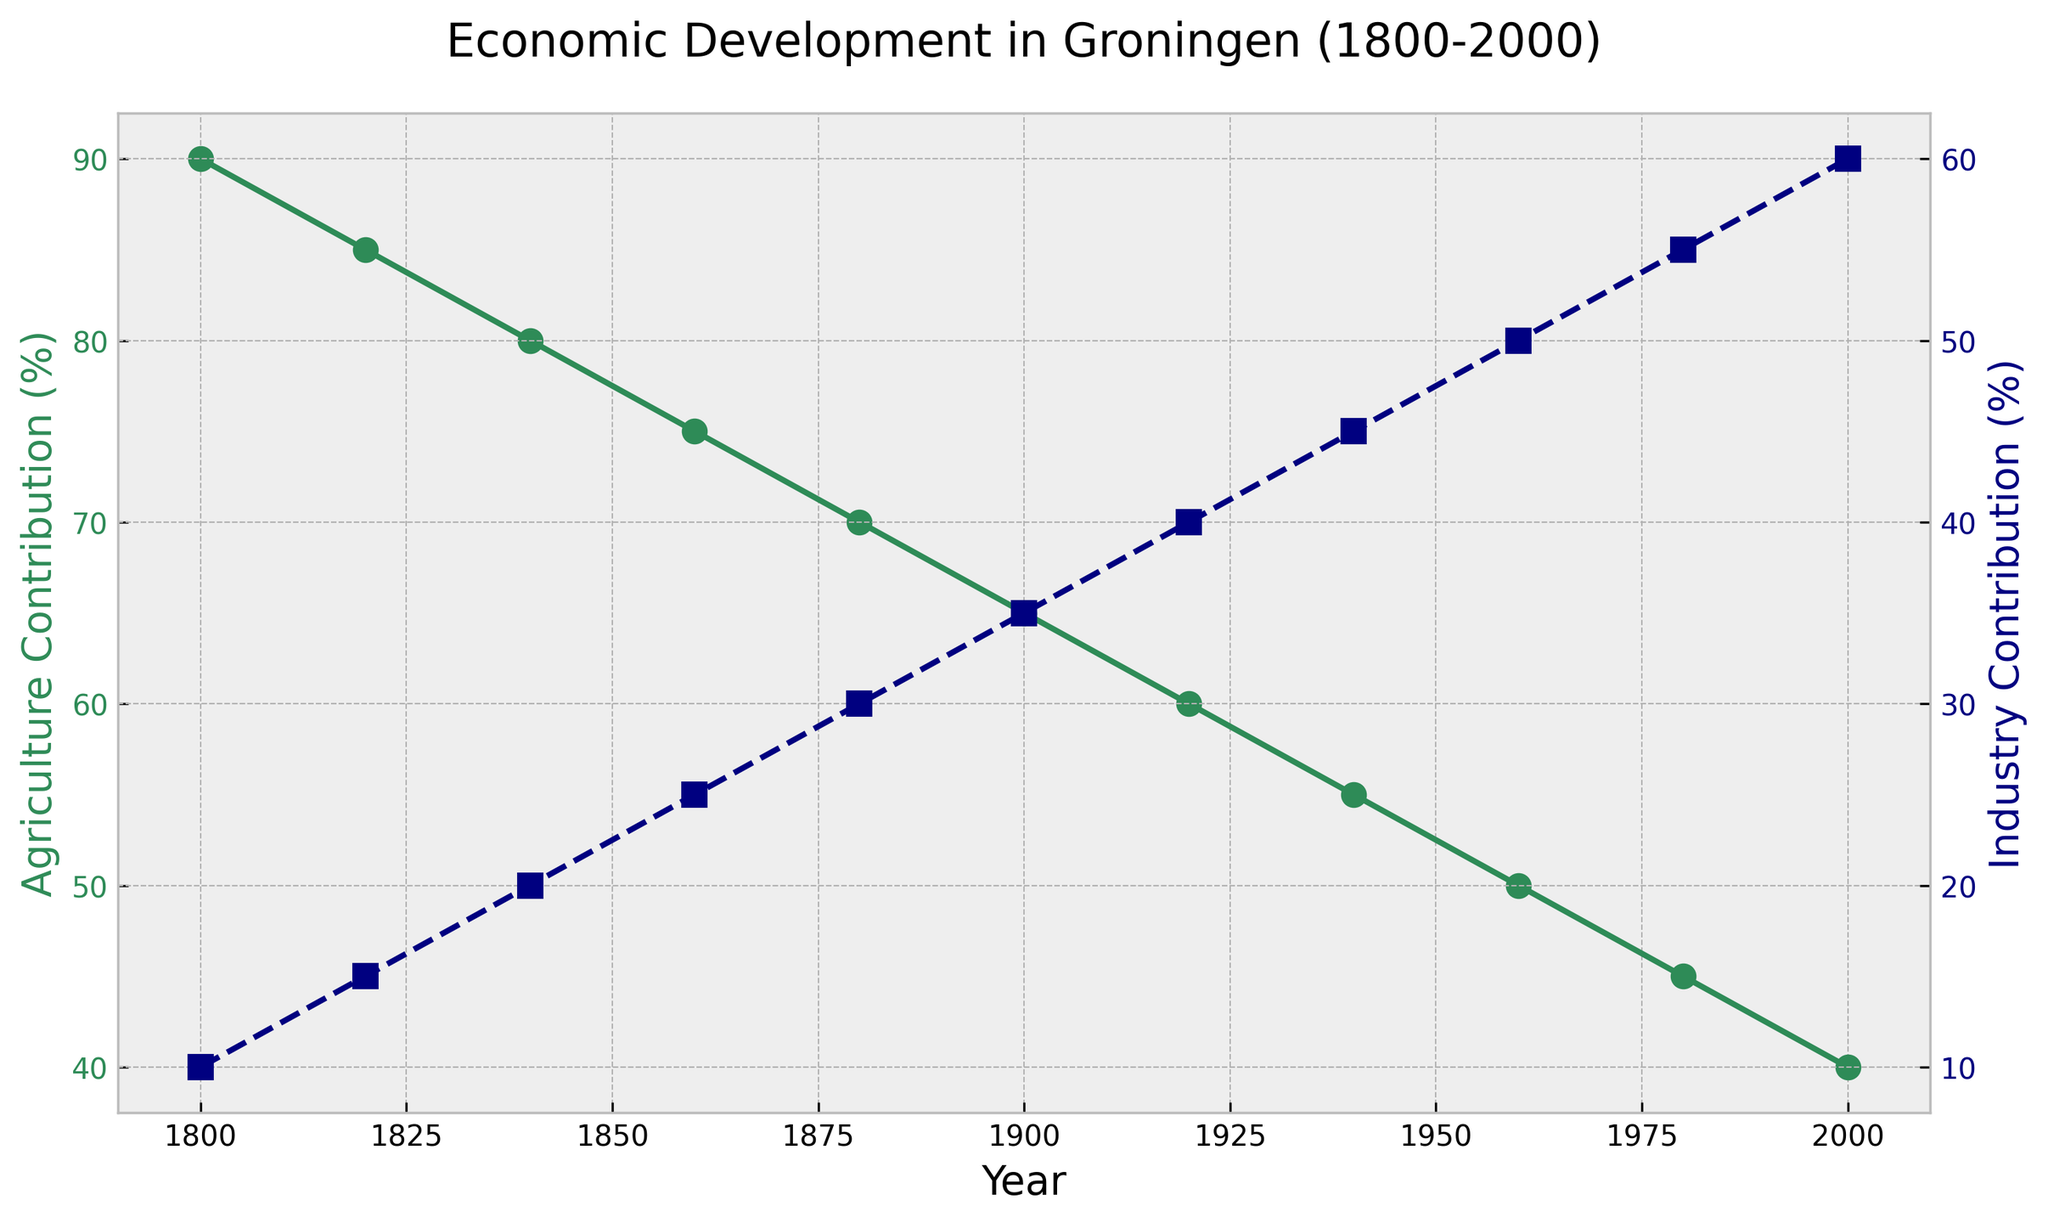What is the trend in the agricultural contribution from 1800 to 2000? The agricultural contribution shows a decreasing trend over time. Initially, in 1800, it was 90%, and by 2000, it had declined to 40%. This continuous decrease indicates a reduction in the importance of agriculture in the economy of Groningen over these 200 years.
Answer: Decreasing When did the agricultural and industrial contributions equal each other? The contributions were equal when both agriculture and industry were at 50%. By looking at the lines for Agriculture and Industry percentages, this happened in the year 1960.
Answer: 1960 What is the absolute difference in industrial contribution between 1800 and 2000? The industrial contribution in 1800 was 10%, and it increased to 60% by 2000. The absolute difference is calculated as 60 - 10.
Answer: 50% Which sector had a higher contribution in 1980, and by how much? In 1980, the agricultural contribution was 45%, and the industrial contribution was 55%. Industrial contribution was higher. The difference is calculated as 55 - 45.
Answer: Industry, 10% How did the contributions of agriculture and industry change between 1900 and 1920? In 1900, the agricultural contribution was 65%, and by 1920, it decreased to 60%. The industrial contribution increased from 35% in 1900 to 40% in 1920. Thus, agriculture decreased by 5%, and industry increased by 5%.
Answer: Agriculture decreased by 5%, Industry increased by 5% What is the trend in the industrial contribution from 1940 to 1980? From 1940 to 1980, the industrial contribution shows an increasing trend. It rose from 45% in 1940 to 55% in 1980. This indicates steady growth in the industrial sector's importance in Groningen's economy during these years.
Answer: Increasing What was the agricultural contribution in 1900, and how does it compare to that in 2000? In 1900, the agricultural contribution was 65%. By 2000, it had decreased to 40%. To compare, agriculture's contribution dropped significantly by 25% over this period.
Answer: 65% in 1900, decreased by 25% by 2000 What are the colors representing agriculture and industry in the plot? The color representing agriculture is seagreen, and the color representing industry is navy. This is based on the visual coding used in the plot to distinguish the two sectors clearly.
Answer: Seagreen (Agriculture), Navy (Industry) By what percentage did the agricultural contribution decrease from 1800 to 1880? In 1800, the agricultural contribution was 90%, and by 1880, it had decreased to 70%. The percentage decrease is calculated as ((90 - 70) / 90) * 100%.
Answer: 22.22% Which sector shows a steadier trend over time, and how can you tell? Agriculture shows a steadier, more linear declining trend over time, whereas the industrial contribution shows a more consistent increase over the years. This steady decline in agriculture as opposed to the more varied increases in industry makes the agricultural contribution appear steadier.
Answer: Agriculture 